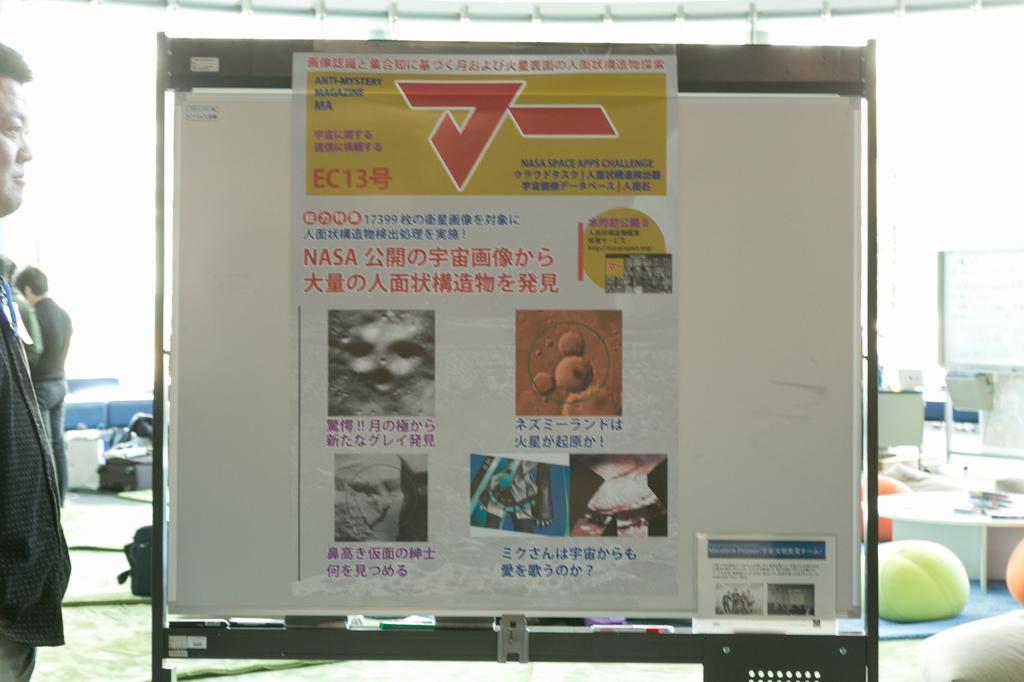What number is next to the ec on the yellow part of sign?
Offer a terse response. 13. What are the four letters in english below the yellow part of the sign?
Your answer should be compact. Nasa. 